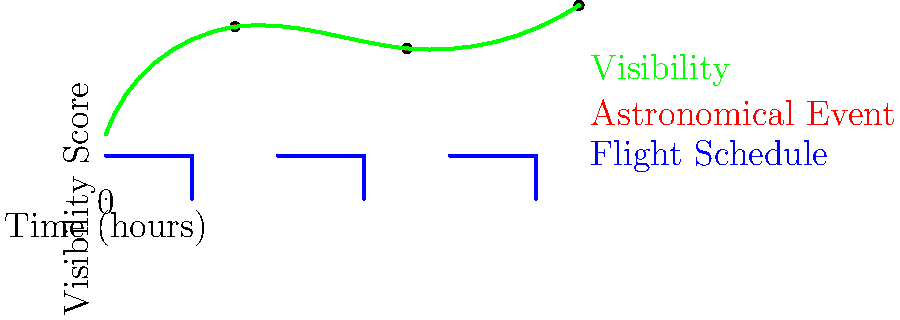Based on the graph showing flight schedules, astronomical events, and visibility at a lesser-known airport, during which time interval would you recommend scheduling a stargazing session to maximize both optimal viewing conditions and the chance to observe a significant astronomical event? To determine the best time for stargazing, we need to analyze the graph considering three factors:

1. Flight schedules: Represented by blue lines, indicating times when stargazing might be disrupted.
2. Astronomical events: Shown as red dots, representing significant celestial occurrences.
3. Visibility: The green curve indicates the quality of viewing conditions.

Step-by-step analysis:

1. Flight schedules are shown at 0-4 hours, 8-12 hours, and 16-20 hours. We should avoid these times.

2. Astronomical events occur at approximately 6, 14, and 22 hours.

3. The visibility curve peaks near these event times, with the highest point around 22 hours.

4. The time intervals between flights are:
   - 4-8 hours
   - 12-16 hours
   - 20-24 hours

5. Comparing these intervals with event times and visibility:
   - 4-8 hours: Includes an event at 6 hours with good visibility.
   - 12-16 hours: Includes an event at 14 hours with slightly lower visibility.
   - 20-24 hours: Includes an event at 22 hours with the highest visibility.

6. The 20-24 hour interval offers the best combination of an astronomical event and peak visibility, while avoiding flight disruptions.

Therefore, the optimal time for stargazing would be in the 20-24 hour interval, specifically around the 22-hour mark.
Answer: 20-24 hour interval 